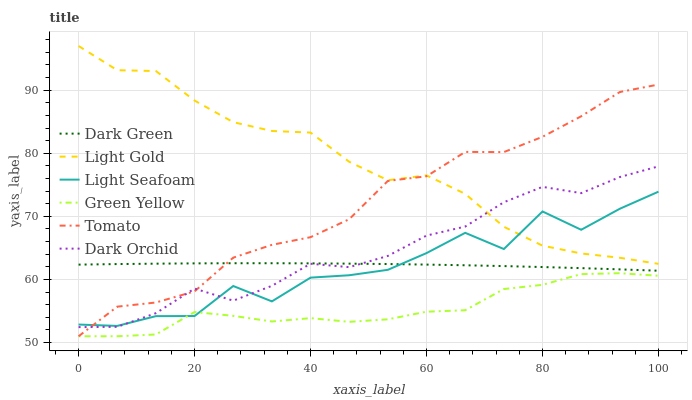Does Green Yellow have the minimum area under the curve?
Answer yes or no. Yes. Does Light Gold have the maximum area under the curve?
Answer yes or no. Yes. Does Light Seafoam have the minimum area under the curve?
Answer yes or no. No. Does Light Seafoam have the maximum area under the curve?
Answer yes or no. No. Is Dark Green the smoothest?
Answer yes or no. Yes. Is Light Seafoam the roughest?
Answer yes or no. Yes. Is Dark Orchid the smoothest?
Answer yes or no. No. Is Dark Orchid the roughest?
Answer yes or no. No. Does Tomato have the lowest value?
Answer yes or no. Yes. Does Light Seafoam have the lowest value?
Answer yes or no. No. Does Light Gold have the highest value?
Answer yes or no. Yes. Does Light Seafoam have the highest value?
Answer yes or no. No. Is Green Yellow less than Dark Green?
Answer yes or no. Yes. Is Light Gold greater than Green Yellow?
Answer yes or no. Yes. Does Light Seafoam intersect Dark Orchid?
Answer yes or no. Yes. Is Light Seafoam less than Dark Orchid?
Answer yes or no. No. Is Light Seafoam greater than Dark Orchid?
Answer yes or no. No. Does Green Yellow intersect Dark Green?
Answer yes or no. No. 